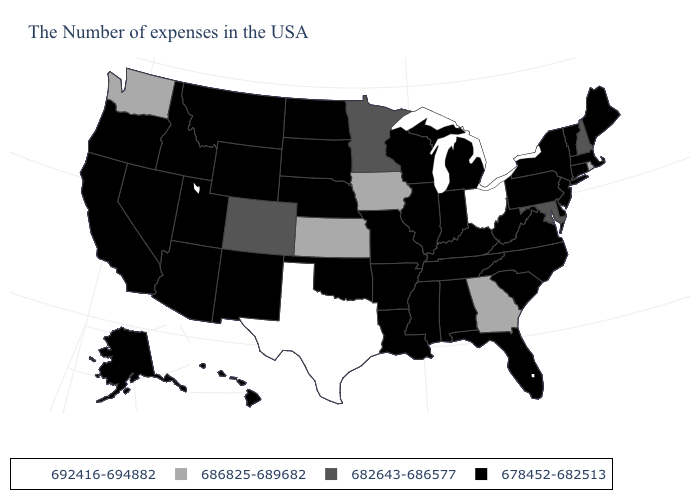What is the value of West Virginia?
Be succinct. 678452-682513. What is the value of Georgia?
Keep it brief. 686825-689682. What is the value of Louisiana?
Concise answer only. 678452-682513. What is the value of Indiana?
Write a very short answer. 678452-682513. Name the states that have a value in the range 686825-689682?
Give a very brief answer. Rhode Island, Georgia, Iowa, Kansas, Washington. What is the value of Georgia?
Quick response, please. 686825-689682. Does Minnesota have the lowest value in the MidWest?
Keep it brief. No. Which states have the lowest value in the South?
Be succinct. Delaware, Virginia, North Carolina, South Carolina, West Virginia, Florida, Kentucky, Alabama, Tennessee, Mississippi, Louisiana, Arkansas, Oklahoma. Name the states that have a value in the range 682643-686577?
Write a very short answer. New Hampshire, Maryland, Minnesota, Colorado. Does the map have missing data?
Be succinct. No. What is the highest value in states that border Illinois?
Answer briefly. 686825-689682. Name the states that have a value in the range 686825-689682?
Quick response, please. Rhode Island, Georgia, Iowa, Kansas, Washington. How many symbols are there in the legend?
Keep it brief. 4. What is the value of Tennessee?
Quick response, please. 678452-682513. Is the legend a continuous bar?
Keep it brief. No. 